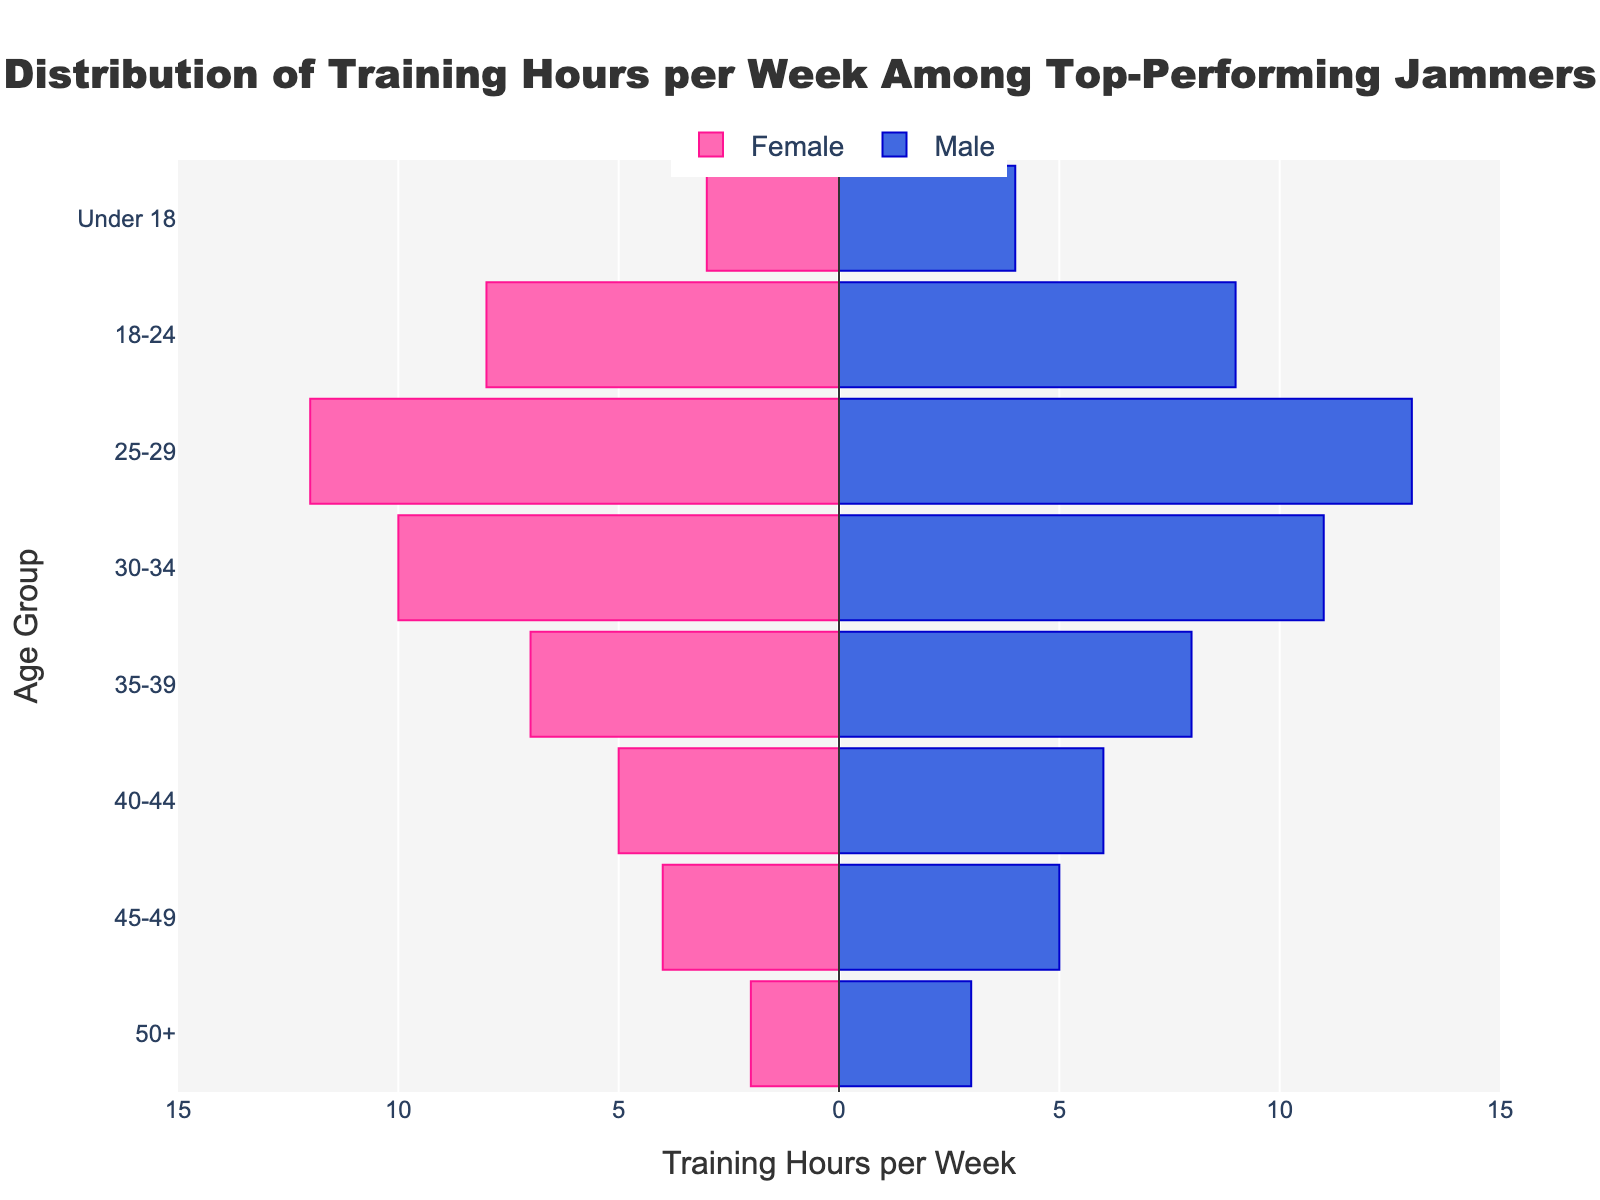What is the title of the figure? The title of the figure is prominently displayed at the top of the plot. You can identify it by its larger font size and central position.
Answer: Distribution of Training Hours per Week Among Top-Performing Jammers How many age groups are present in the plot? To find the number of age groups, count the distinct categories listed along the y-axis.
Answer: 8 Which age group has the highest training hours for males? Look at the length of the blue bars representing male training hours. The longest bar indicates the highest training hours.
Answer: 25-29 How do female training hours for the age group 18-24 compare to those of males? Compare the lengths of the pink bar and the blue bar for the age group 18-24. The magnitude of the values can be observed from the x-axis.
Answer: Females have less training hours compared to males (8 vs. 9) What is the difference in training hours between males and females in the 50+ age group? Subtract the training hours of females from that of males for the age group 50+.
Answer: 1 Which age group has the smallest gender difference in training hours? The age group with the smallest difference in bar lengths (absolute values on both sides of the zero line) represents the smallest gender difference.
Answer: 25-29 What is the total training time per week for females across all age groups? Sum up the training hours for females across all age groups. The values are 3 + 8 + 12 + 10 + 7 + 5 + 4 + 2.
Answer: 51 What is the ratio of male to female training hours for the age group 35-39? Divide the training hours of males by the training hours of females for the age group 35-39 (8 divided by 7).
Answer: ~1.14 Which gender consistently trains more across most age groups? By visually inspecting the relative lengths of bars for each age group, determine which gender's bars are generally longer.
Answer: Males How does the training distribution of Under 18 compare to that of 45-49 for males? Compare the lengths of the blue bars for the age groups Under 18 and 45-49. Observe if the training hours are more, less, or equal.
Answer: They are equal (both have 4 and 5, respectively) 